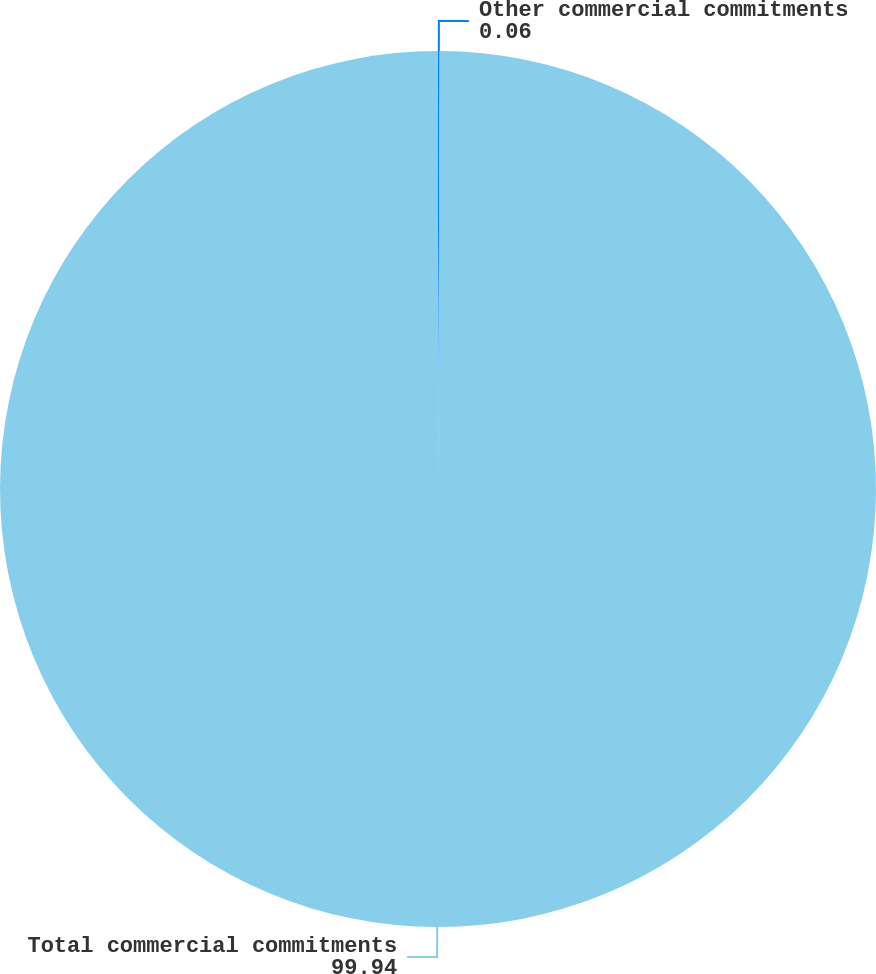<chart> <loc_0><loc_0><loc_500><loc_500><pie_chart><fcel>Other commercial commitments<fcel>Total commercial commitments<nl><fcel>0.06%<fcel>99.94%<nl></chart> 